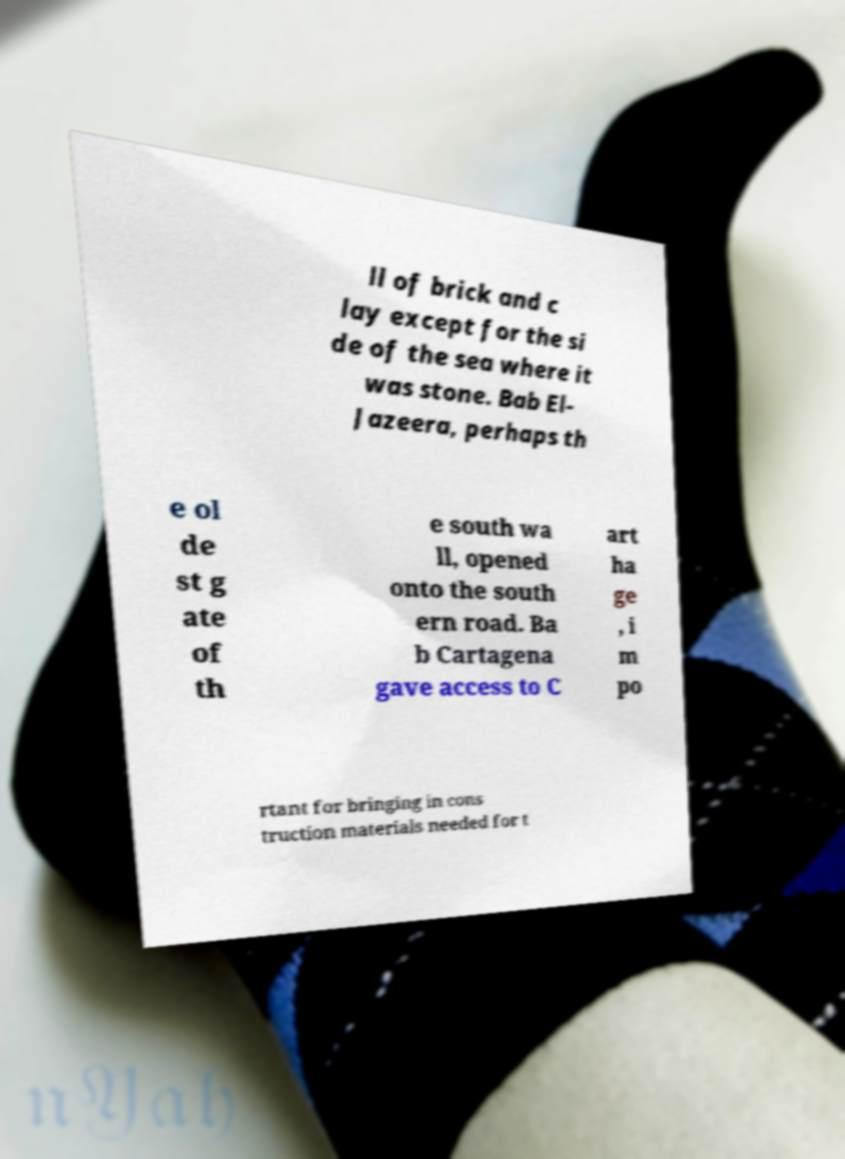Could you extract and type out the text from this image? ll of brick and c lay except for the si de of the sea where it was stone. Bab El- Jazeera, perhaps th e ol de st g ate of th e south wa ll, opened onto the south ern road. Ba b Cartagena gave access to C art ha ge , i m po rtant for bringing in cons truction materials needed for t 